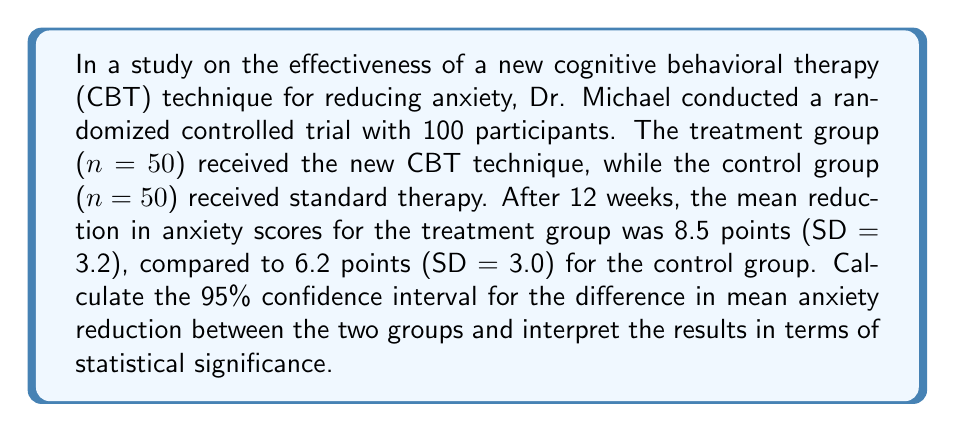Help me with this question. To calculate the 95% confidence interval for the difference in mean anxiety reduction between the two groups, we'll follow these steps:

1. Calculate the standard error of the difference between means:
   The formula for the standard error of the difference is:
   
   $$ SE = \sqrt{\frac{s_1^2}{n_1} + \frac{s_2^2}{n_2}} $$
   
   Where $s_1$ and $s_2$ are the standard deviations, and $n_1$ and $n_2$ are the sample sizes.

   $$ SE = \sqrt{\frac{3.2^2}{50} + \frac{3.0^2}{50}} = \sqrt{0.2048 + 0.18} = \sqrt{0.3848} = 0.62 $$

2. Calculate the difference in means:
   $$ \bar{x}_1 - \bar{x}_2 = 8.5 - 6.2 = 2.3 $$

3. Determine the critical value for a 95% confidence interval:
   For a large sample size (n > 30), we use the z-score of 1.96 for a 95% CI.

4. Calculate the margin of error:
   $$ \text{Margin of Error} = 1.96 \times SE = 1.96 \times 0.62 = 1.22 $$

5. Calculate the 95% confidence interval:
   $$ CI = (\bar{x}_1 - \bar{x}_2) \pm \text{Margin of Error} $$
   $$ CI = 2.3 \pm 1.22 $$
   $$ CI = (1.08, 3.52) $$

Interpretation:
We can be 95% confident that the true difference in mean anxiety reduction between the new CBT technique and standard therapy lies between 1.08 and 3.52 points. Since the confidence interval does not include 0, we can conclude that the difference is statistically significant at the 0.05 level.

To further support this conclusion, we can calculate the p-value:

6. Calculate the z-score:
   $$ z = \frac{\bar{x}_1 - \bar{x}_2}{SE} = \frac{2.3}{0.62} = 3.71 $$

7. Find the p-value using a z-table or calculator:
   The p-value for a two-tailed test with z = 3.71 is approximately 0.0002.

Since the p-value (0.0002) is less than the significance level (0.05), we reject the null hypothesis and conclude that there is a statistically significant difference between the new CBT technique and standard therapy in reducing anxiety.
Answer: The 95% confidence interval for the difference in mean anxiety reduction between the two groups is (1.08, 3.52). This interval does not include 0, indicating a statistically significant difference at the 0.05 level. The p-value of 0.0002 further confirms the statistical significance of the results, suggesting that the new CBT technique is more effective than standard therapy in reducing anxiety. 